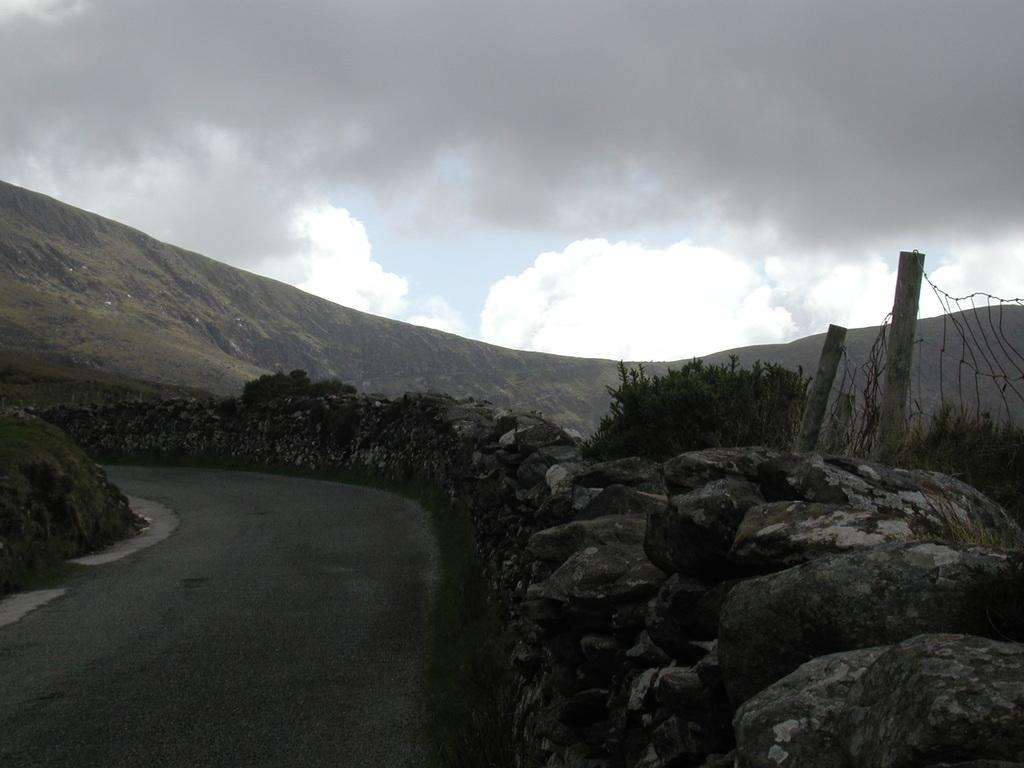What is the main feature in the center of the image? There is a road in the center of the image. What can be seen on the right side of the image? There are rocks on the right side of the image. What type of barrier is present in the image? There is a fence in the image. What type of natural scenery is visible in the background of the image? There are trees, mountains, and the sky visible in the background of the image. What type of paper is being used to create the mountains in the image? There is no paper present in the image; the mountains are a natural feature in the background. 